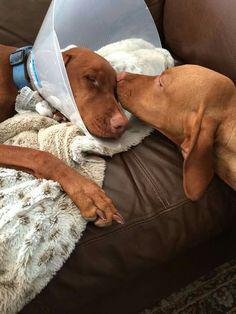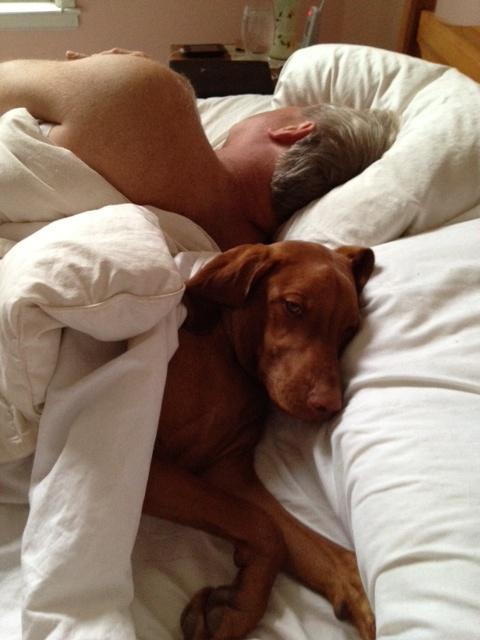The first image is the image on the left, the second image is the image on the right. Evaluate the accuracy of this statement regarding the images: "The right image shows a red-orange dog reclining in a bed with the side of its head on a pillow.". Is it true? Answer yes or no. Yes. The first image is the image on the left, the second image is the image on the right. Considering the images on both sides, is "There are only two dogs in total." valid? Answer yes or no. No. 